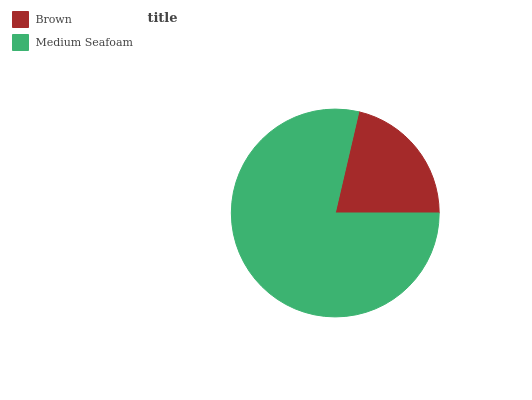Is Brown the minimum?
Answer yes or no. Yes. Is Medium Seafoam the maximum?
Answer yes or no. Yes. Is Medium Seafoam the minimum?
Answer yes or no. No. Is Medium Seafoam greater than Brown?
Answer yes or no. Yes. Is Brown less than Medium Seafoam?
Answer yes or no. Yes. Is Brown greater than Medium Seafoam?
Answer yes or no. No. Is Medium Seafoam less than Brown?
Answer yes or no. No. Is Medium Seafoam the high median?
Answer yes or no. Yes. Is Brown the low median?
Answer yes or no. Yes. Is Brown the high median?
Answer yes or no. No. Is Medium Seafoam the low median?
Answer yes or no. No. 